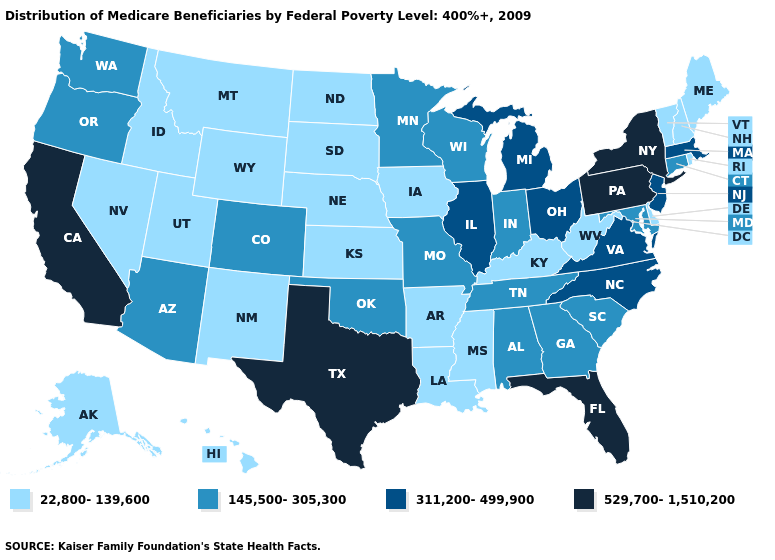Which states have the lowest value in the USA?
Short answer required. Alaska, Arkansas, Delaware, Hawaii, Idaho, Iowa, Kansas, Kentucky, Louisiana, Maine, Mississippi, Montana, Nebraska, Nevada, New Hampshire, New Mexico, North Dakota, Rhode Island, South Dakota, Utah, Vermont, West Virginia, Wyoming. Name the states that have a value in the range 529,700-1,510,200?
Give a very brief answer. California, Florida, New York, Pennsylvania, Texas. What is the value of Missouri?
Concise answer only. 145,500-305,300. Among the states that border New Mexico , which have the highest value?
Concise answer only. Texas. Does Alaska have the lowest value in the USA?
Write a very short answer. Yes. Does Indiana have the lowest value in the USA?
Short answer required. No. What is the value of South Dakota?
Write a very short answer. 22,800-139,600. Name the states that have a value in the range 145,500-305,300?
Keep it brief. Alabama, Arizona, Colorado, Connecticut, Georgia, Indiana, Maryland, Minnesota, Missouri, Oklahoma, Oregon, South Carolina, Tennessee, Washington, Wisconsin. What is the highest value in states that border Oklahoma?
Keep it brief. 529,700-1,510,200. Among the states that border North Dakota , which have the lowest value?
Write a very short answer. Montana, South Dakota. Does the first symbol in the legend represent the smallest category?
Concise answer only. Yes. What is the lowest value in states that border Texas?
Write a very short answer. 22,800-139,600. What is the value of Hawaii?
Keep it brief. 22,800-139,600. Name the states that have a value in the range 145,500-305,300?
Be succinct. Alabama, Arizona, Colorado, Connecticut, Georgia, Indiana, Maryland, Minnesota, Missouri, Oklahoma, Oregon, South Carolina, Tennessee, Washington, Wisconsin. How many symbols are there in the legend?
Answer briefly. 4. 